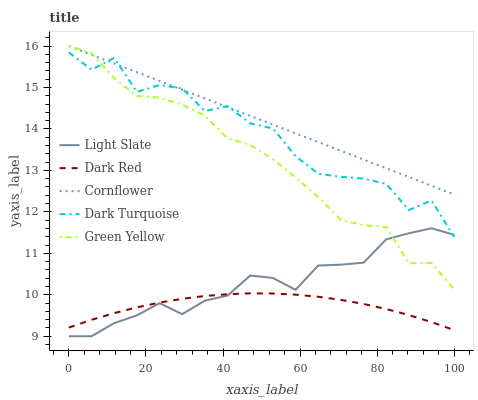Does Dark Red have the minimum area under the curve?
Answer yes or no. Yes. Does Cornflower have the maximum area under the curve?
Answer yes or no. Yes. Does Green Yellow have the minimum area under the curve?
Answer yes or no. No. Does Green Yellow have the maximum area under the curve?
Answer yes or no. No. Is Cornflower the smoothest?
Answer yes or no. Yes. Is Dark Turquoise the roughest?
Answer yes or no. Yes. Is Dark Red the smoothest?
Answer yes or no. No. Is Dark Red the roughest?
Answer yes or no. No. Does Light Slate have the lowest value?
Answer yes or no. Yes. Does Dark Red have the lowest value?
Answer yes or no. No. Does Cornflower have the highest value?
Answer yes or no. Yes. Does Dark Red have the highest value?
Answer yes or no. No. Is Dark Red less than Cornflower?
Answer yes or no. Yes. Is Dark Turquoise greater than Dark Red?
Answer yes or no. Yes. Does Green Yellow intersect Dark Turquoise?
Answer yes or no. Yes. Is Green Yellow less than Dark Turquoise?
Answer yes or no. No. Is Green Yellow greater than Dark Turquoise?
Answer yes or no. No. Does Dark Red intersect Cornflower?
Answer yes or no. No. 